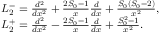Convert formula to latex. <formula><loc_0><loc_0><loc_500><loc_500>\begin{array} { r l } & { L _ { 2 } ^ { - } = \frac { d ^ { 2 } } { d x ^ { 2 } } + \frac { 2 S _ { 0 } - 1 } { x } \frac { d } { d x } + \frac { S _ { 0 } ( S _ { 0 } - 2 ) } { x ^ { 2 } } , } \\ & { L _ { 2 } ^ { + } = \frac { d ^ { 2 } } { d x ^ { 2 } } - \frac { 2 S _ { 0 } - 1 } { x } \frac { d } { d x } + \frac { S _ { 0 } ^ { 2 } - 1 } { x ^ { 2 } } . } \end{array}</formula> 